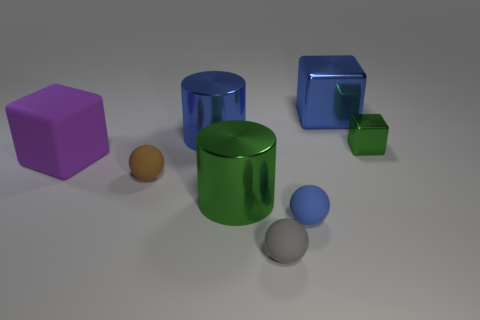How many things are either large metallic things that are in front of the large blue cube or small things to the right of the blue cylinder?
Your answer should be very brief. 5. What number of blue matte balls are to the left of the large cylinder that is behind the brown object?
Your answer should be compact. 0. Does the green object in front of the small brown sphere have the same shape as the blue object that is in front of the small green cube?
Your answer should be compact. No. There is a big thing that is the same color as the tiny shiny thing; what is its shape?
Offer a terse response. Cylinder. Are there any large green objects made of the same material as the blue cylinder?
Provide a short and direct response. Yes. How many metal things are blue spheres or big blue cubes?
Provide a succinct answer. 1. What shape is the blue object that is in front of the green shiny thing that is behind the brown sphere?
Make the answer very short. Sphere. Are there fewer large green things that are to the left of the big blue shiny cube than gray cubes?
Your answer should be very brief. No. What is the shape of the large green thing?
Your response must be concise. Cylinder. There is a gray rubber ball to the left of the tiny block; what size is it?
Provide a short and direct response. Small. 